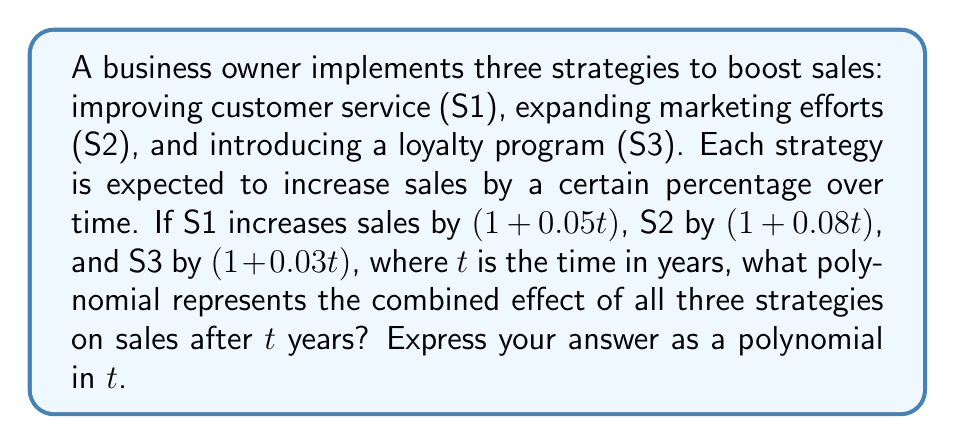Can you solve this math problem? To find the combined effect of all three strategies, we need to multiply the polynomials representing each strategy:

1) Strategy 1: $(1 + 0.05t)$
2) Strategy 2: $(1 + 0.08t)$
3) Strategy 3: $(1 + 0.03t)$

Let's multiply these polynomials:

$$(1 + 0.05t)(1 + 0.08t)(1 + 0.03t)$$

First, multiply the first two terms:

$$(1 + 0.05t)(1 + 0.08t) = 1 + 0.08t + 0.05t + 0.004t^2 = 1 + 0.13t + 0.004t^2$$

Now, multiply this result by the third term:

$$(1 + 0.13t + 0.004t^2)(1 + 0.03t)$$

Distribute:
1) $1 \cdot (1 + 0.03t) = 1 + 0.03t$
2) $0.13t \cdot (1 + 0.03t) = 0.13t + 0.0039t^2$
3) $0.004t^2 \cdot (1 + 0.03t) = 0.004t^2 + 0.00012t^3$

Sum all terms:

$$1 + 0.03t + 0.13t + 0.0039t^2 + 0.004t^2 + 0.00012t^3$$

Combine like terms:

$$1 + 0.16t + 0.0079t^2 + 0.00012t^3$$

This polynomial represents the combined effect of all three strategies on sales after $t$ years.
Answer: $1 + 0.16t + 0.0079t^2 + 0.00012t^3$ 